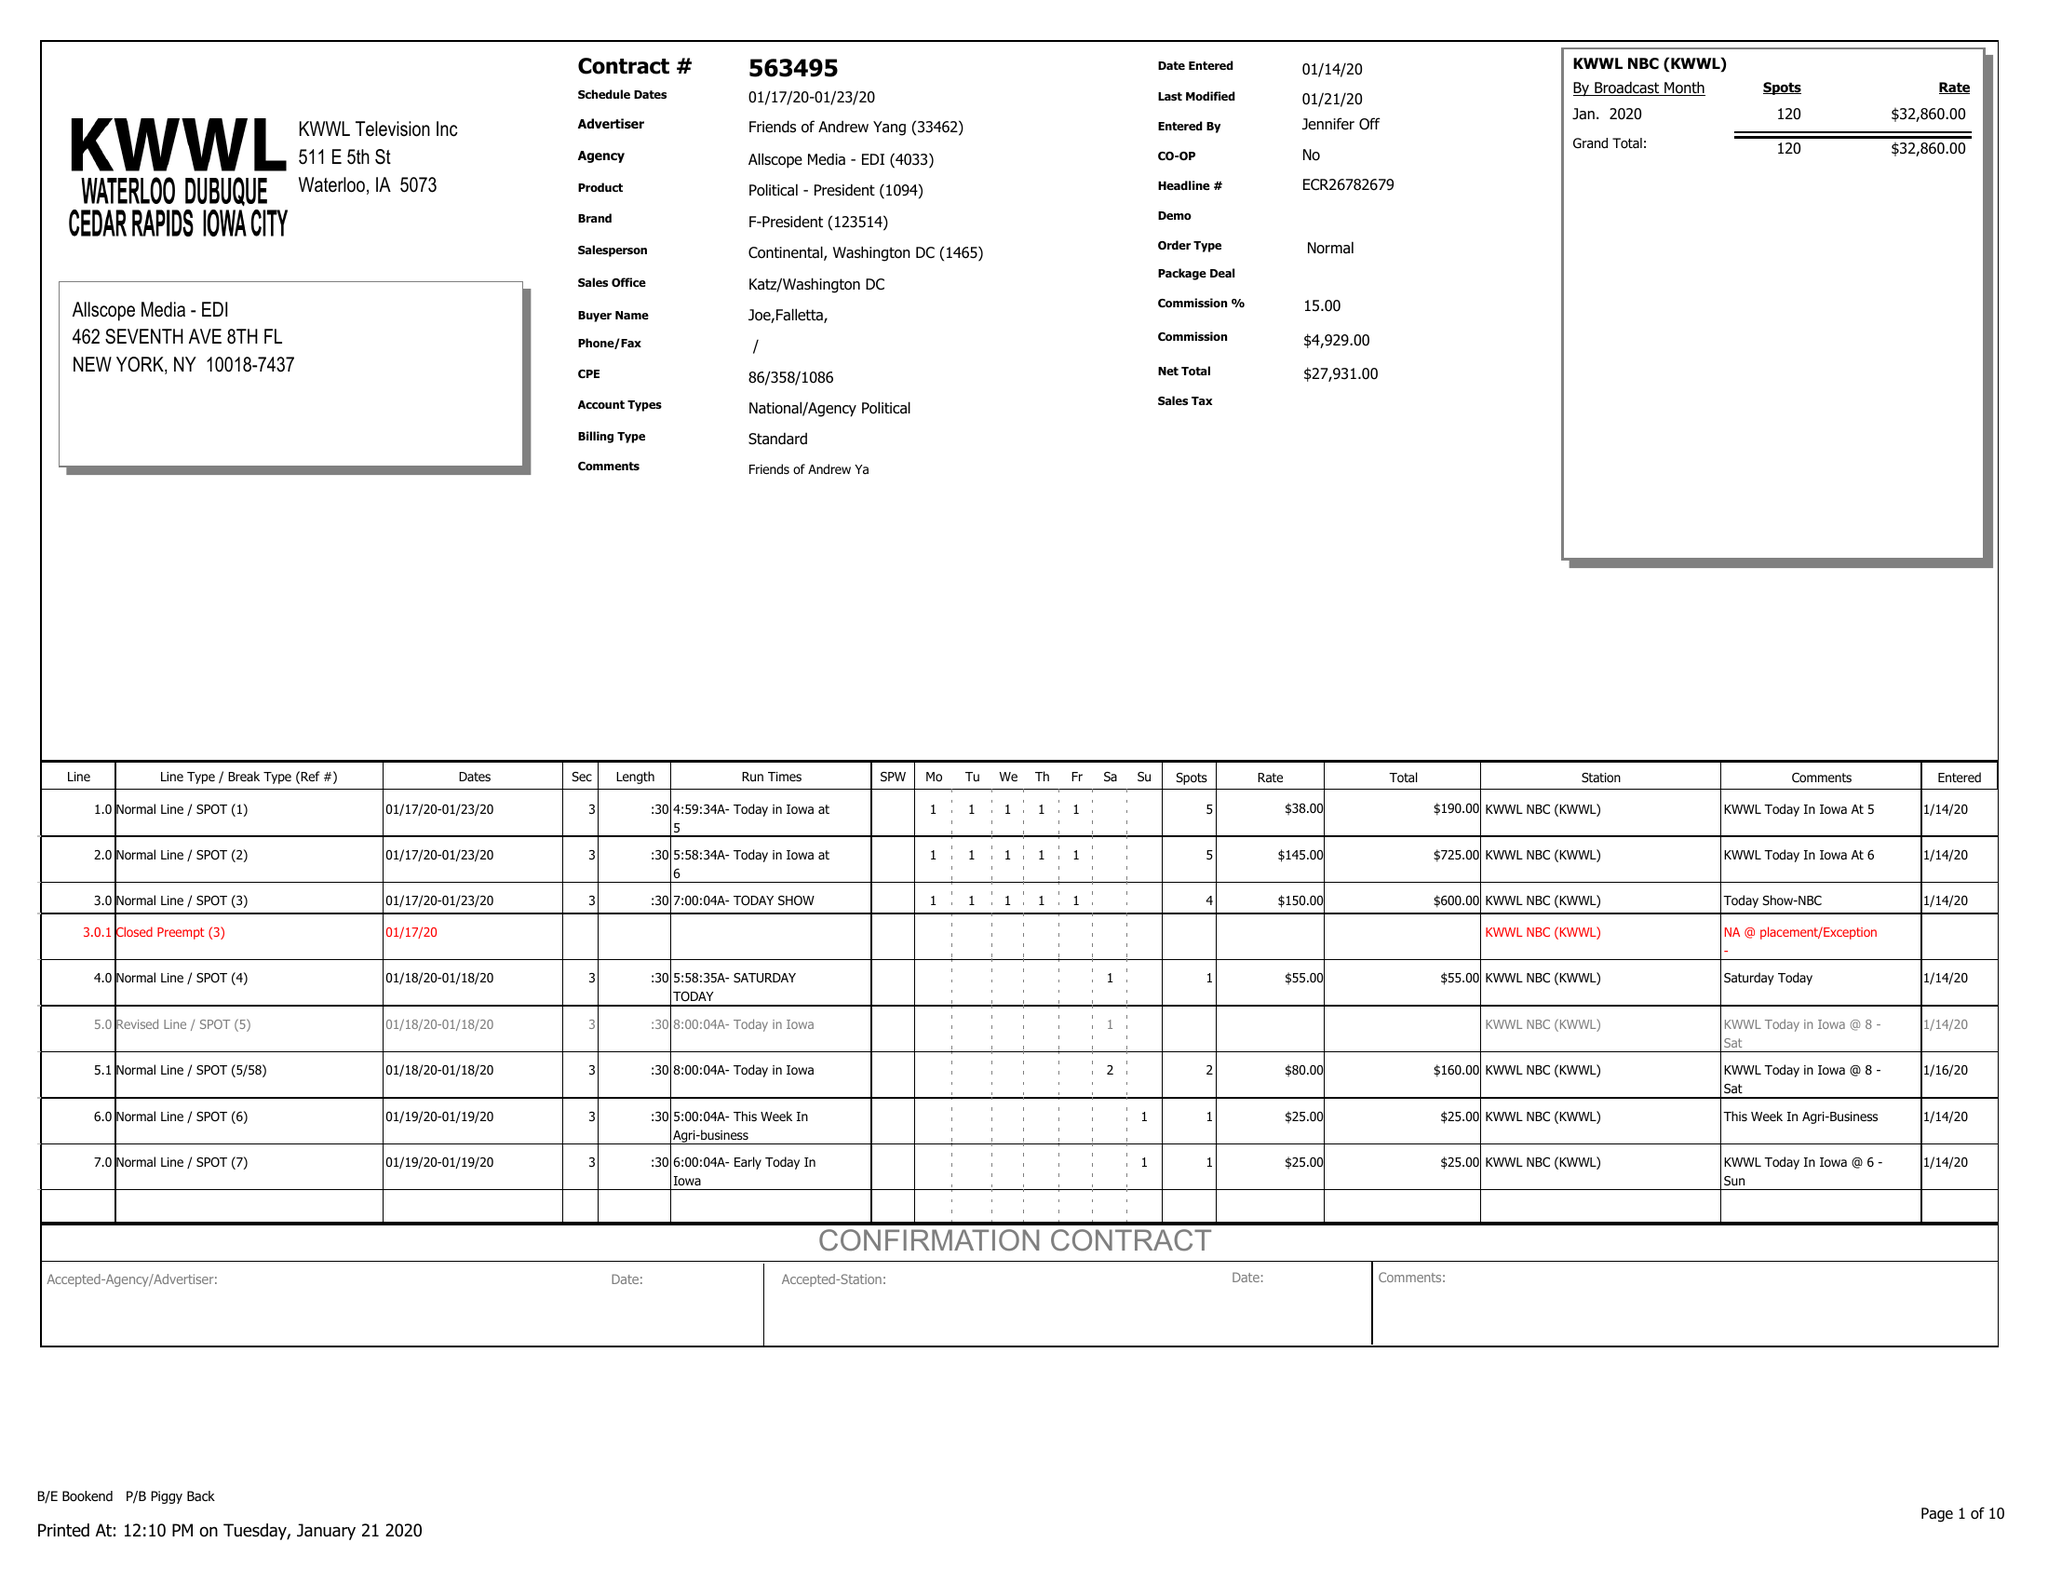What is the value for the advertiser?
Answer the question using a single word or phrase. FRIENDS OF ANDREW YANG 